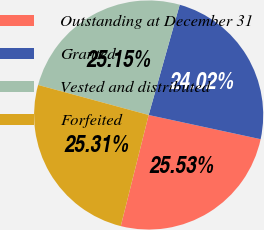<chart> <loc_0><loc_0><loc_500><loc_500><pie_chart><fcel>Outstanding at December 31<fcel>Granted<fcel>Vested and distributed<fcel>Forfeited<nl><fcel>25.53%<fcel>24.02%<fcel>25.15%<fcel>25.31%<nl></chart> 